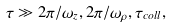<formula> <loc_0><loc_0><loc_500><loc_500>\tau \gg { 2 \pi } / { \omega _ { z } } , { 2 \pi } / { \omega _ { \rho } } , \tau _ { c o l l } ,</formula> 